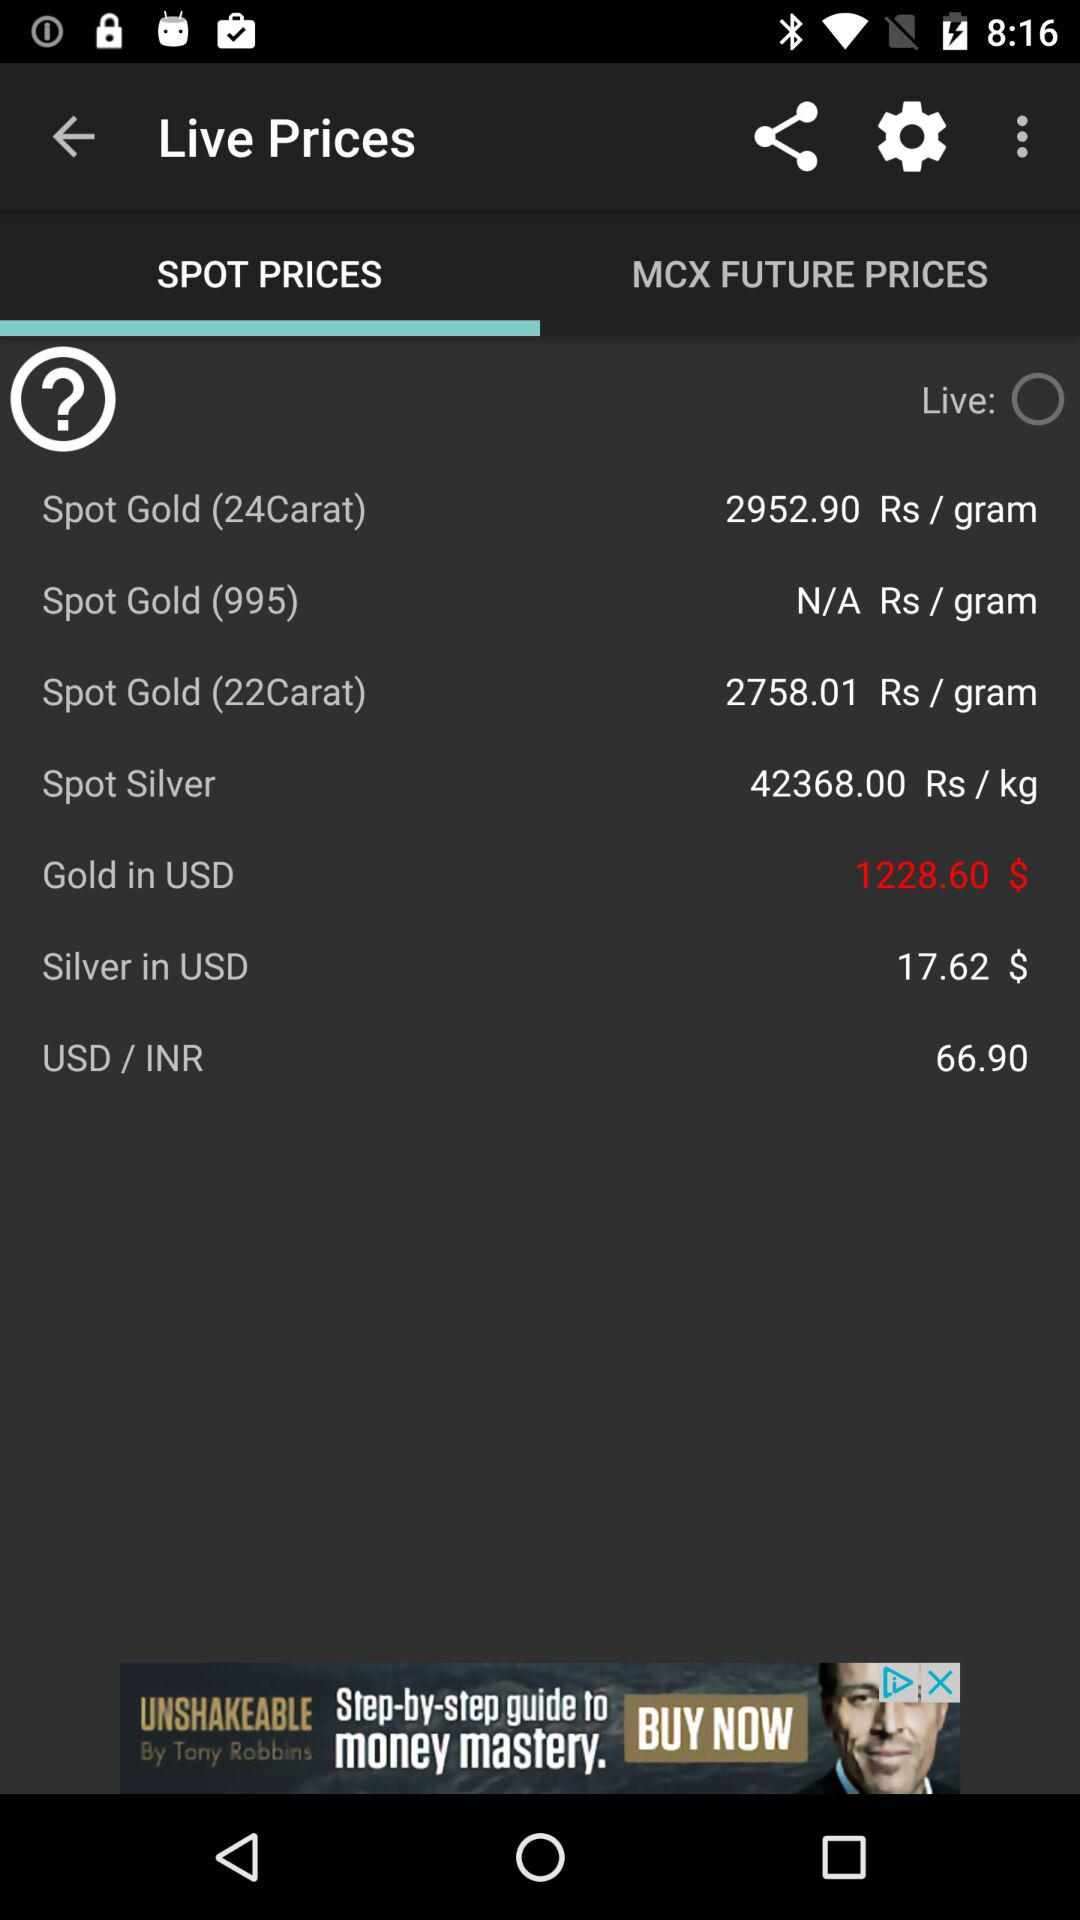What is the spot price of "Gold" in USD? The spot price of "Gold" in USD is $1228.60. 